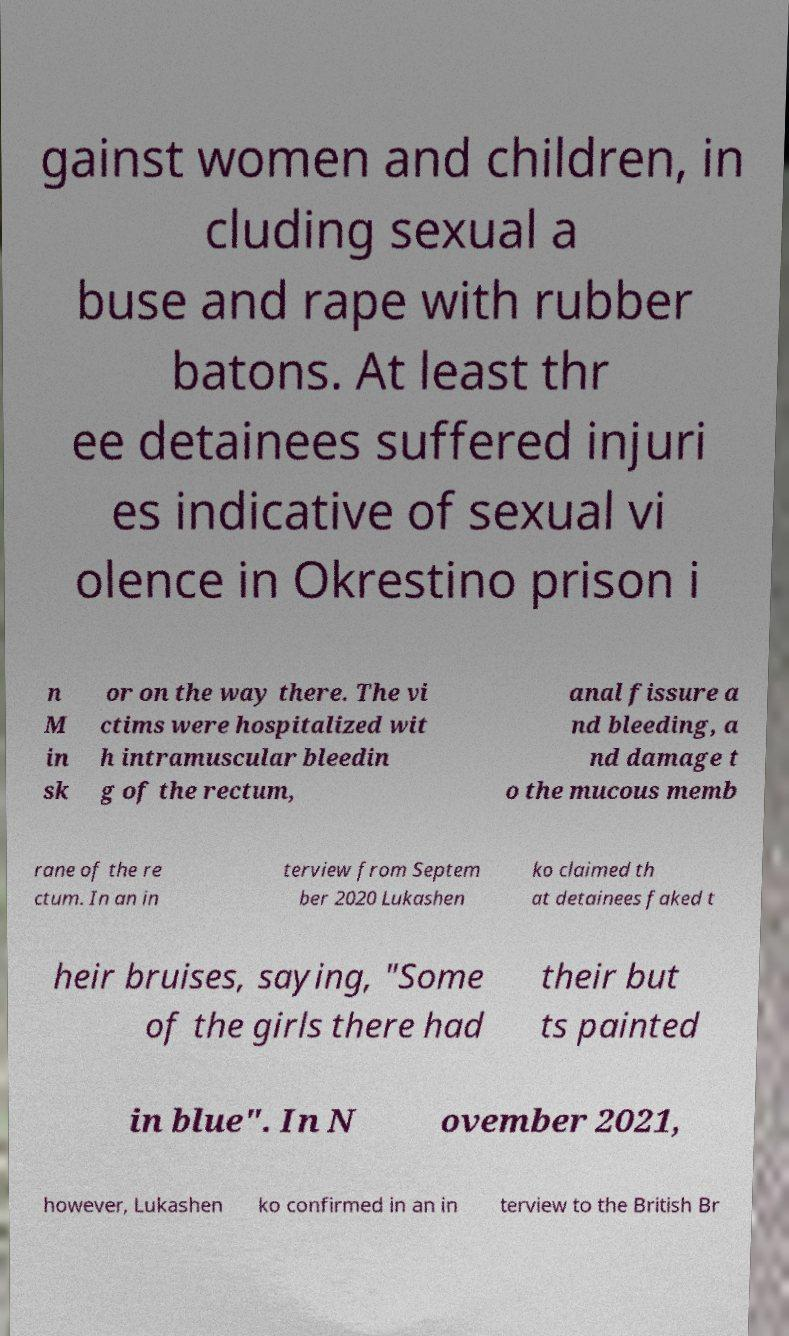Could you assist in decoding the text presented in this image and type it out clearly? gainst women and children, in cluding sexual a buse and rape with rubber batons. At least thr ee detainees suffered injuri es indicative of sexual vi olence in Okrestino prison i n M in sk or on the way there. The vi ctims were hospitalized wit h intramuscular bleedin g of the rectum, anal fissure a nd bleeding, a nd damage t o the mucous memb rane of the re ctum. In an in terview from Septem ber 2020 Lukashen ko claimed th at detainees faked t heir bruises, saying, "Some of the girls there had their but ts painted in blue". In N ovember 2021, however, Lukashen ko confirmed in an in terview to the British Br 